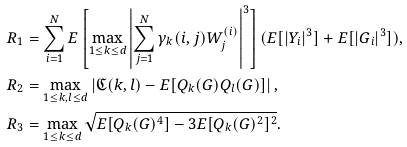<formula> <loc_0><loc_0><loc_500><loc_500>R _ { 1 } & = \sum _ { i = 1 } ^ { N } E \left [ \max _ { 1 \leq k \leq d } \left | \sum _ { j = 1 } ^ { N } \gamma _ { k } ( i , j ) W ^ { ( i ) } _ { j } \right | ^ { 3 } \right ] ( E [ | Y _ { i } | ^ { 3 } ] + E [ | G _ { i } | ^ { 3 } ] ) , \\ R _ { 2 } & = \max _ { 1 \leq k , l \leq d } \left | \mathfrak { C } ( k , l ) - E [ Q _ { k } ( G ) Q _ { l } ( G ) ] \right | , \\ R _ { 3 } & = \max _ { 1 \leq k \leq d } \sqrt { E [ Q _ { k } ( G ) ^ { 4 } ] - 3 E [ Q _ { k } ( G ) ^ { 2 } ] ^ { 2 } } .</formula> 